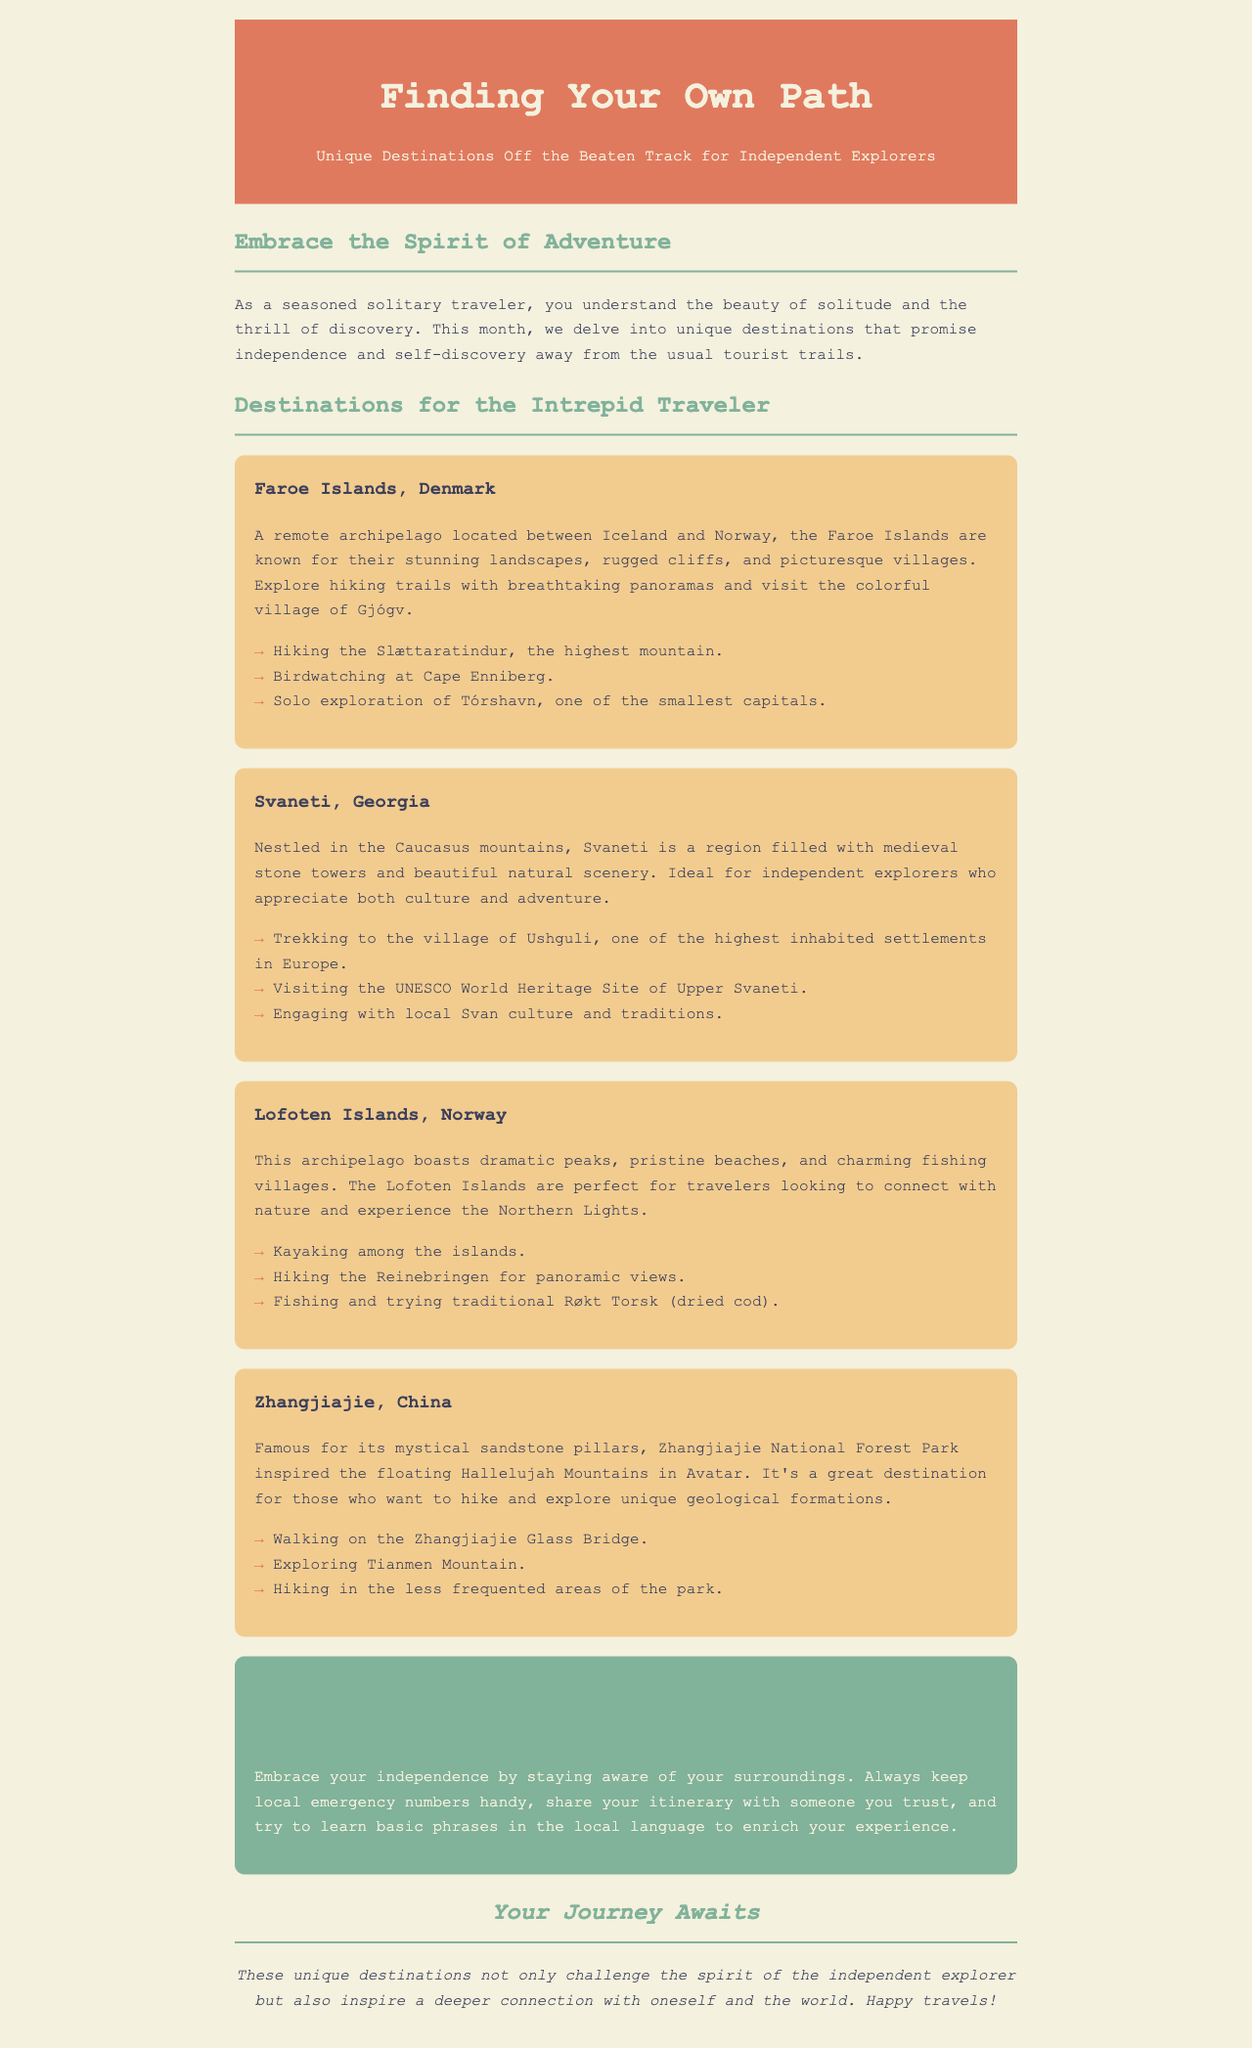What is the title of the newsletter? The title is located in the header section of the document, stating the focus of the content clearly.
Answer: Finding Your Own Path What is the first destination mentioned in the newsletter? The first destination listed in the "Destinations for the Intrepid Traveler" section is highlighted as one of the unique locations for independent explorers.
Answer: Faroe Islands, Denmark How many hiking activities are suggested for the Lofoten Islands? The section on Lofoten Islands lists three specific activities, including hiking, within the formatting of bullet points.
Answer: Three Which country is Svaneti located in? The information is provided in the description for Svaneti, specifically naming the country in which this destination resides.
Answer: Georgia What is one of the expert tips provided for solo travel? The expert tips section focuses on safety and suggests practical advice for solitary travelers based on the content provided.
Answer: Stay aware of your surroundings What unique natural feature is Zhangjiajie famous for? The document emphasizes a distinct landmark found in Zhangjiajie as a significant reason to visit this particular destination.
Answer: Sandstone pillars What activity is recommended for birdwatching in the Faroe Islands? The textual reference in the Faroe Islands section provides a specific location for birdwatching among the activities listed.
Answer: Cape Enniberg How does the newsletter encourage independent exploration? The document outlines the theme of adventure and personal growth, emphasizing the journey of discovering unique places.
Answer: Embrace the Spirit of Adventure 